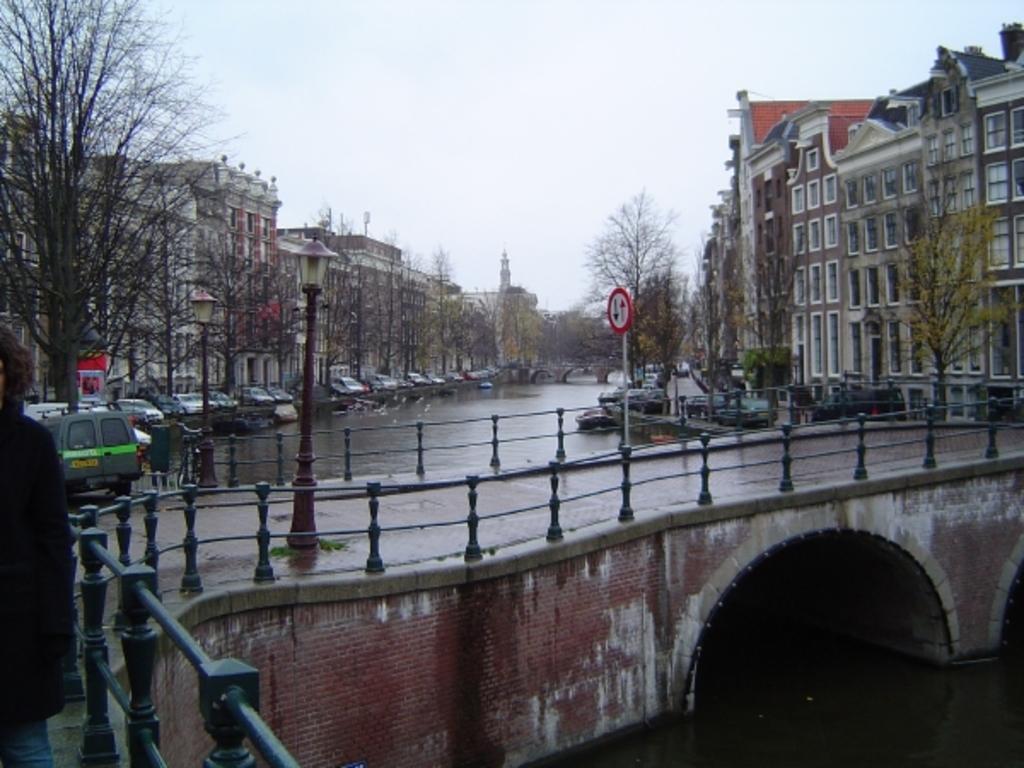Please provide a concise description of this image. In this image, we can see bridge, railings, brick wall, street lights, person, water and pole with sign board. Background we can see vehicles, trees, buildings, walls, bridge, windows and sky. 